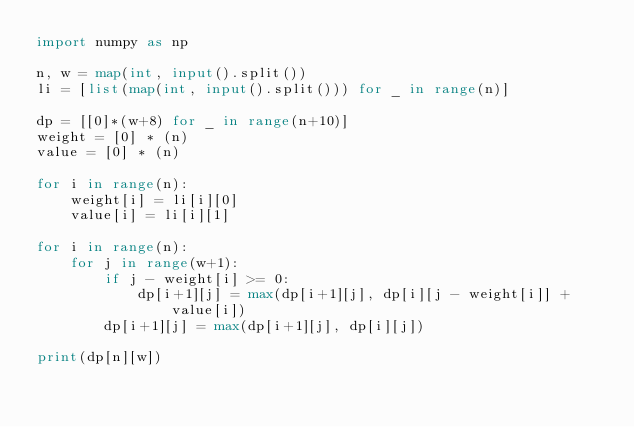<code> <loc_0><loc_0><loc_500><loc_500><_Python_>import numpy as np

n, w = map(int, input().split())
li = [list(map(int, input().split())) for _ in range(n)]

dp = [[0]*(w+8) for _ in range(n+10)]
weight = [0] * (n)
value = [0] * (n)

for i in range(n):
    weight[i] = li[i][0]
    value[i] = li[i][1]

for i in range(n):
    for j in range(w+1):
        if j - weight[i] >= 0:
            dp[i+1][j] = max(dp[i+1][j], dp[i][j - weight[i]] + value[i])
        dp[i+1][j] = max(dp[i+1][j], dp[i][j])

print(dp[n][w])</code> 